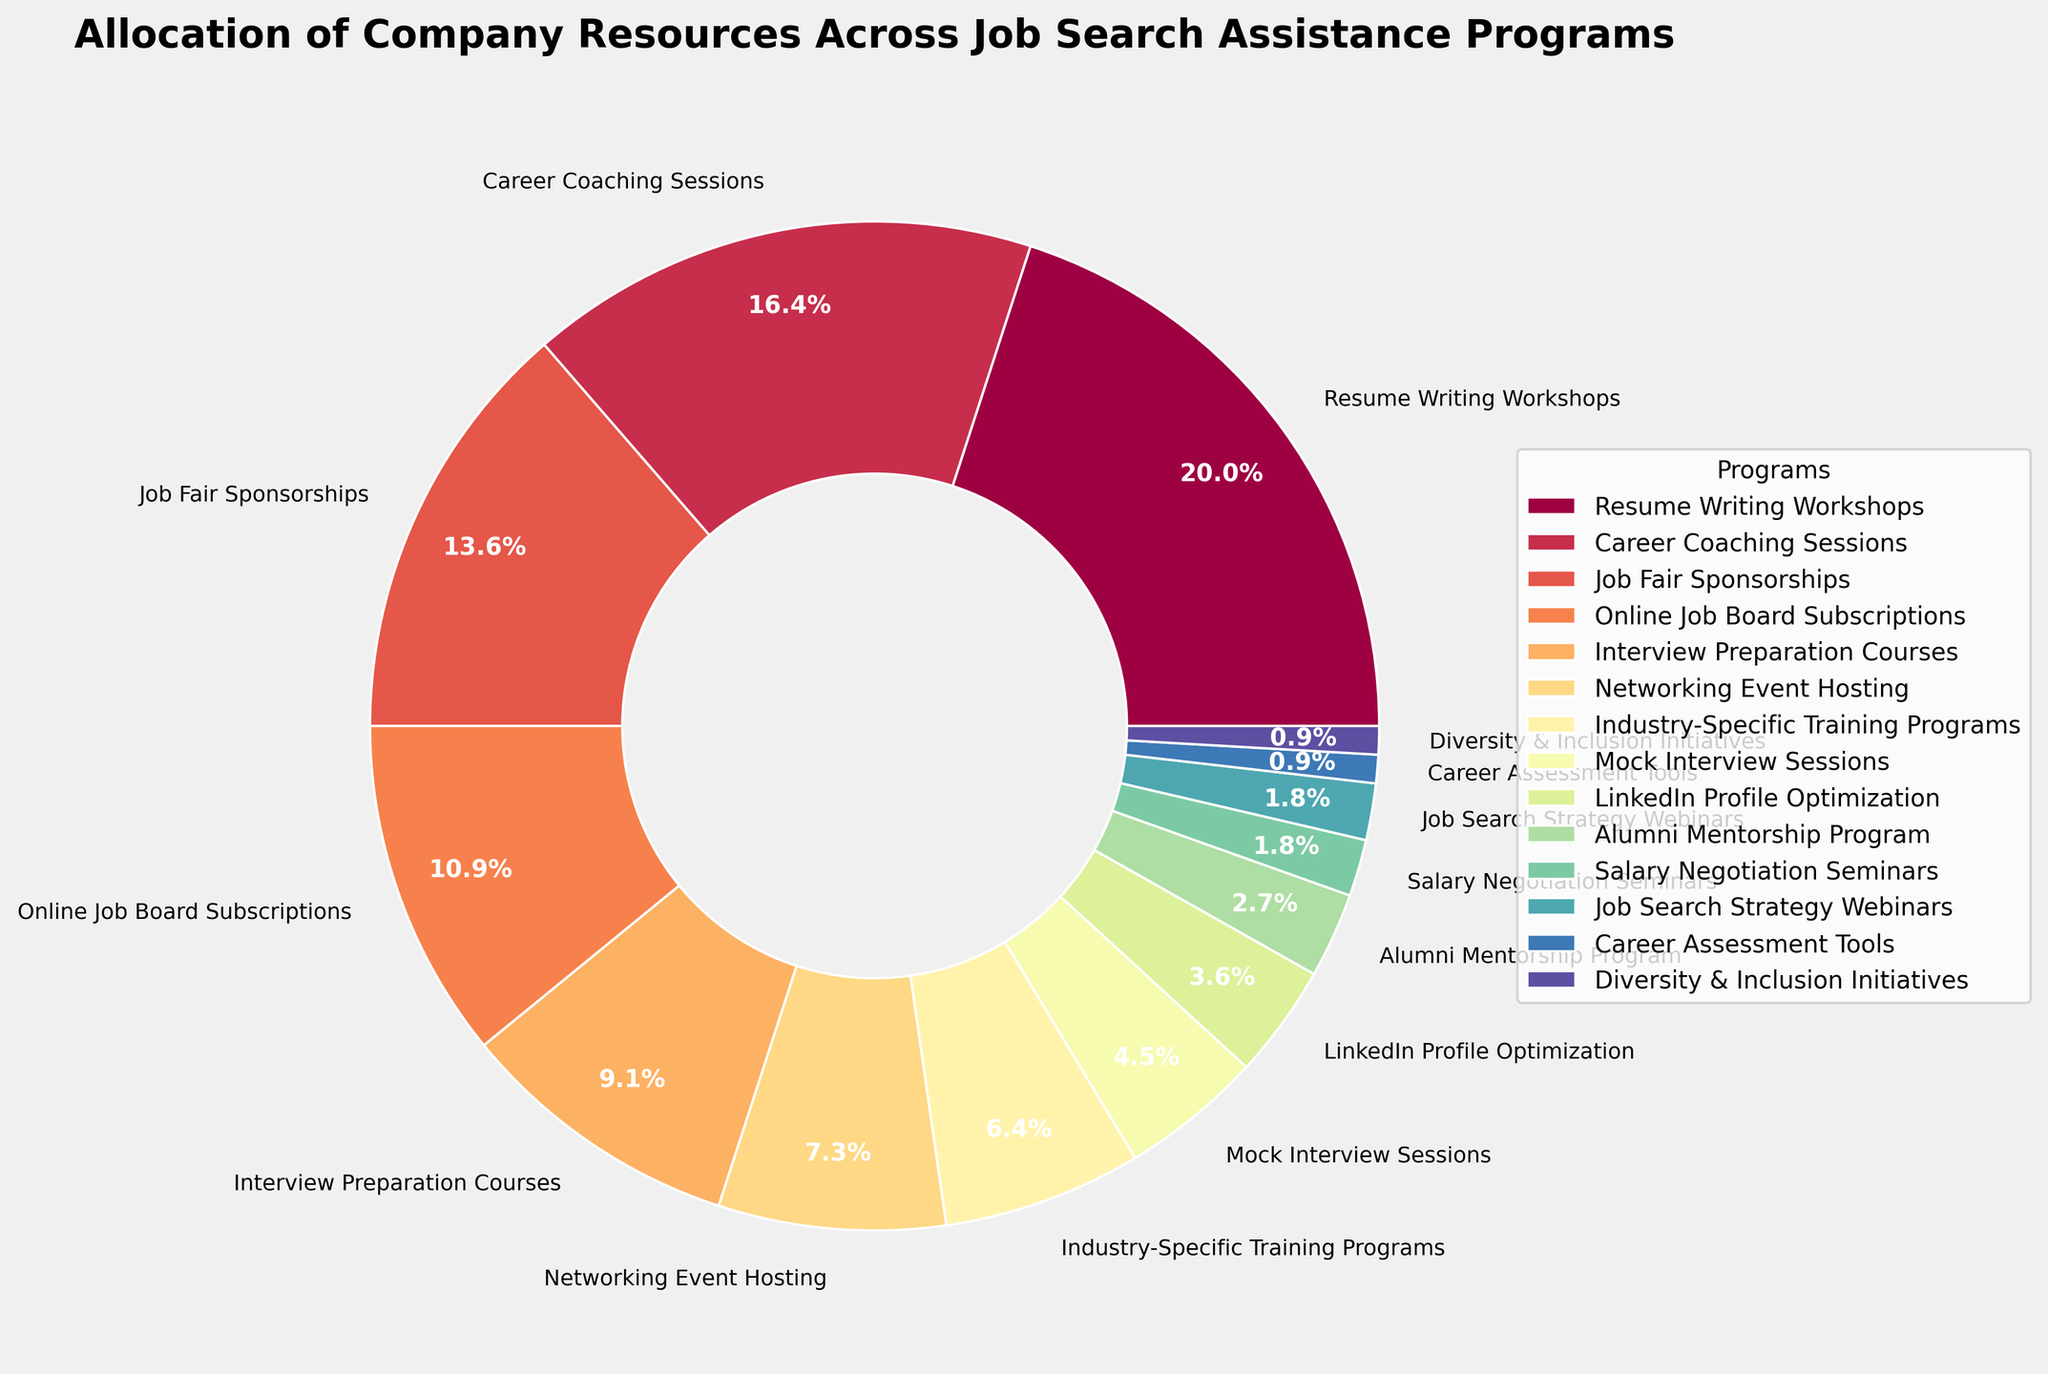What percentage of resources are allocated to the top three job search assistance programs? The top three programs are Resume Writing Workshops (22%), Career Coaching Sessions (18%), and Job Fair Sponsorships (15%). Summing these percentages gives 22 + 18 + 15 = 55%.
Answer: 55% Which program receives the least amount of resources and what is its percentage? The program receiving the least resources is Diversity & Inclusion Initiatives, with 1%.
Answer: Diversity & Inclusion Initiatives, 1% How much more percentage of resources is allocated to Resume Writing Workshops compared to LinkedIn Profile Optimization? Resume Writing Workshops receive 22% and LinkedIn Profile Optimization receives 4%. The difference is 22 - 4 = 18%.
Answer: 18% What is the combined percentage of resources allocated to Industry-Specific Training Programs, Mock Interview Sessions, and LinkedIn Profile Optimization? Industry-Specific Training Programs receive 7%, Mock Interview Sessions receive 5%, and LinkedIn Profile Optimization receives 4%. The combined percentage is 7 + 5 + 4 = 16%.
Answer: 16% Which segment on the pie chart is visually identifiable as the largest, and what is its color? The largest segment, visually identifiable by its size, represents Resume Writing Workshops. Its color can be seen as the lightest, yellowish hue on the pie chart.
Answer: Resume Writing Workshops, yellowish Out of the following programs: Job Fair Sponsorships, Networking Event Hosting, and Alumni Mentorship Program, which one has the highest allocation and what is its percentage? Among these programs, Job Fair Sponsorships has the highest allocation with 15%.
Answer: Job Fair Sponsorships, 15% When comparing Career Coaching Sessions and Interview Preparation Courses, which receives more resources and by how much? Career Coaching Sessions receive 18% whereas Interview Preparation Courses receive 10%. The difference is 18 - 10 = 8%.
Answer: Career Coaching Sessions, 8% What is the average percentage allocated to programs receiving exactly 2% of the resources? The programs with exactly 2% are Salary Negotiation Seminars and Job Search Strategy Webinars. The average is (2 + 2) / 2 = 2%.
Answer: 2% Estimate the number of programs that receive less than 5% of the resources. From the pie chart, the programs receiving less than 5% are LinkedIn Profile Optimization (4%), Alumni Mentorship Program (3%), Salary Negotiation Seminars (2%), Job Search Strategy Webinars (2%), Career Assessment Tools (1%), and Diversity & Inclusion Initiatives (1%). That totals 6 programs.
Answer: 6 